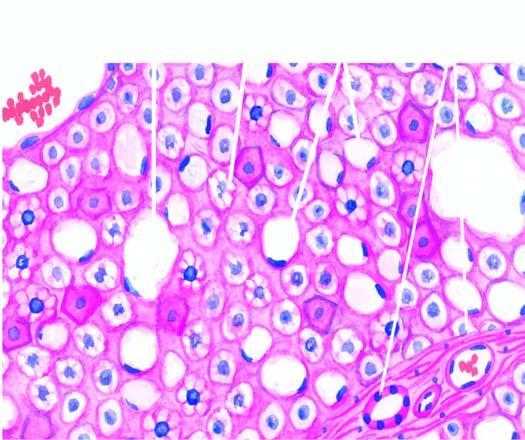what are distended with large fat vacuoles pushing the nuclei to the periphery macrovesicles, while others show multiple small vacuoles in the cytoplasm microvesicles?
Answer the question using a single word or phrase. Many of hepatocytes 